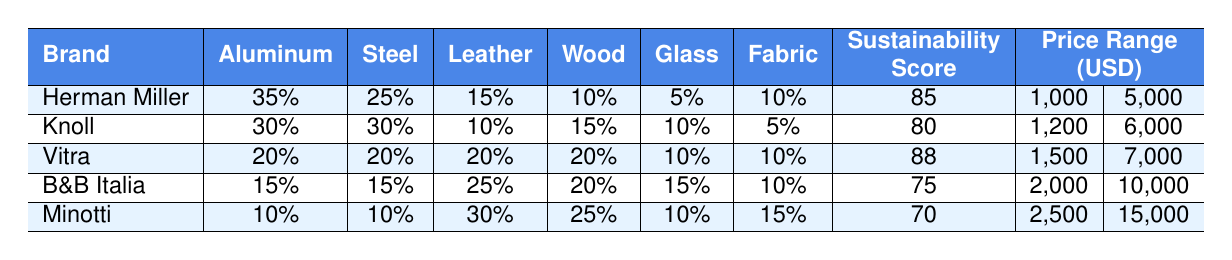What percentage of materials used by B&B Italia is leather? According to the table, B&B Italia uses 25% leather in their furniture.
Answer: 25% Which brand has the highest sustainability score? The table shows that Vitra has the highest sustainability score of 88.
Answer: Vitra What is the average price range of Herman Miller furniture? The price range for Herman Miller is from $1,000 to $5,000. Therefore, the average is calculated as (1000 + 5000) / 2 = 3000.
Answer: $3,000 Is the percentage of wood used by Knoll higher than that of B&B Italia? Knoll uses 15% wood while B&B Italia uses 20% wood. Since 15% is not higher than 20%, the answer is false.
Answer: No What is the total percentage of Aluminum and Steel used by Vitra? Vitra uses 20% Aluminum and 20% Steel. The total percentage is calculated by adding these values: 20 + 20 = 40.
Answer: 40% Which brand uses the lowest percentage of glass? The data shows that Herman Miller uses 5% glass, which is the lowest compared to other brands.
Answer: Herman Miller Can we say that Minotti has more leather than aluminum? Minotti uses 30% leather and 10% aluminum; thus, 30% is more than 10%, making the statement true.
Answer: Yes How does the average sustainability score of Herman Miller and Knoll compare? Herman Miller has a sustainability score of 85, while Knoll has 80. The difference is 85 - 80 = 5, showing that Herman Miller scores higher.
Answer: Herman Miller scores higher What is the total price range (in USD) for all brands combined? The maximum price across brands is $15,000 (Minotti), and the minimum is $1,000 (Herman Miller). Thus, the total range spans from 1,000 to 15,000.
Answer: $1,000 to $15,000 Which brand has the highest percentage of fabric in its furniture? Looking at the data, B&B Italia and Knoll both have 10% fabric, but there is no brand with a higher value. Thus, this percentage is equal among the two.
Answer: None; both have the highest proportion of 10% 